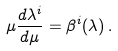<formula> <loc_0><loc_0><loc_500><loc_500>\mu \frac { d \lambda ^ { i } } { d \mu } = \beta ^ { i } ( \lambda ) \, .</formula> 